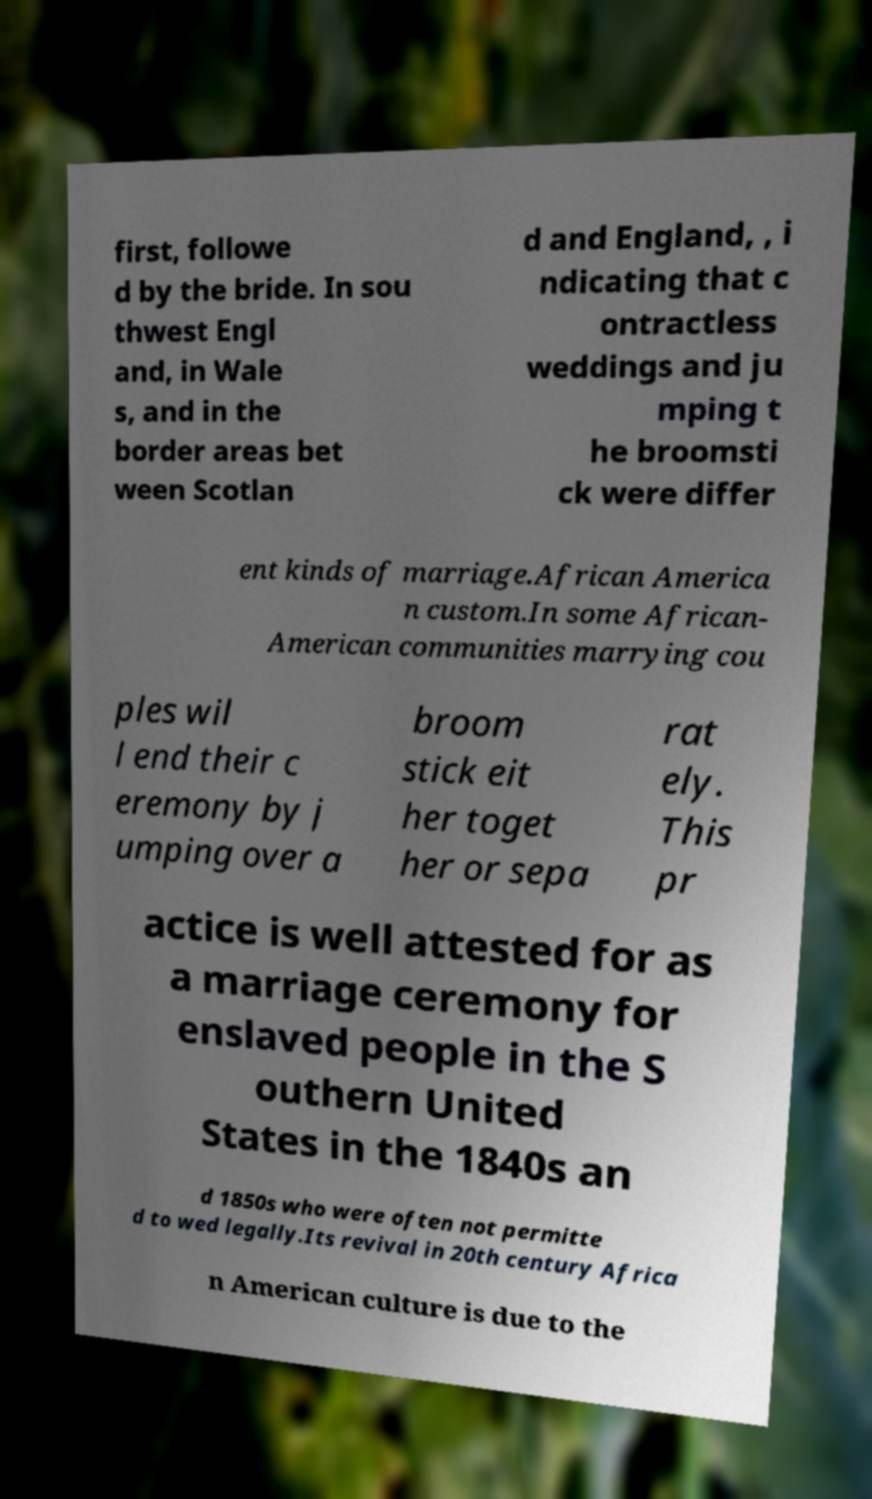There's text embedded in this image that I need extracted. Can you transcribe it verbatim? first, followe d by the bride. In sou thwest Engl and, in Wale s, and in the border areas bet ween Scotlan d and England, , i ndicating that c ontractless weddings and ju mping t he broomsti ck were differ ent kinds of marriage.African America n custom.In some African- American communities marrying cou ples wil l end their c eremony by j umping over a broom stick eit her toget her or sepa rat ely. This pr actice is well attested for as a marriage ceremony for enslaved people in the S outhern United States in the 1840s an d 1850s who were often not permitte d to wed legally.Its revival in 20th century Africa n American culture is due to the 